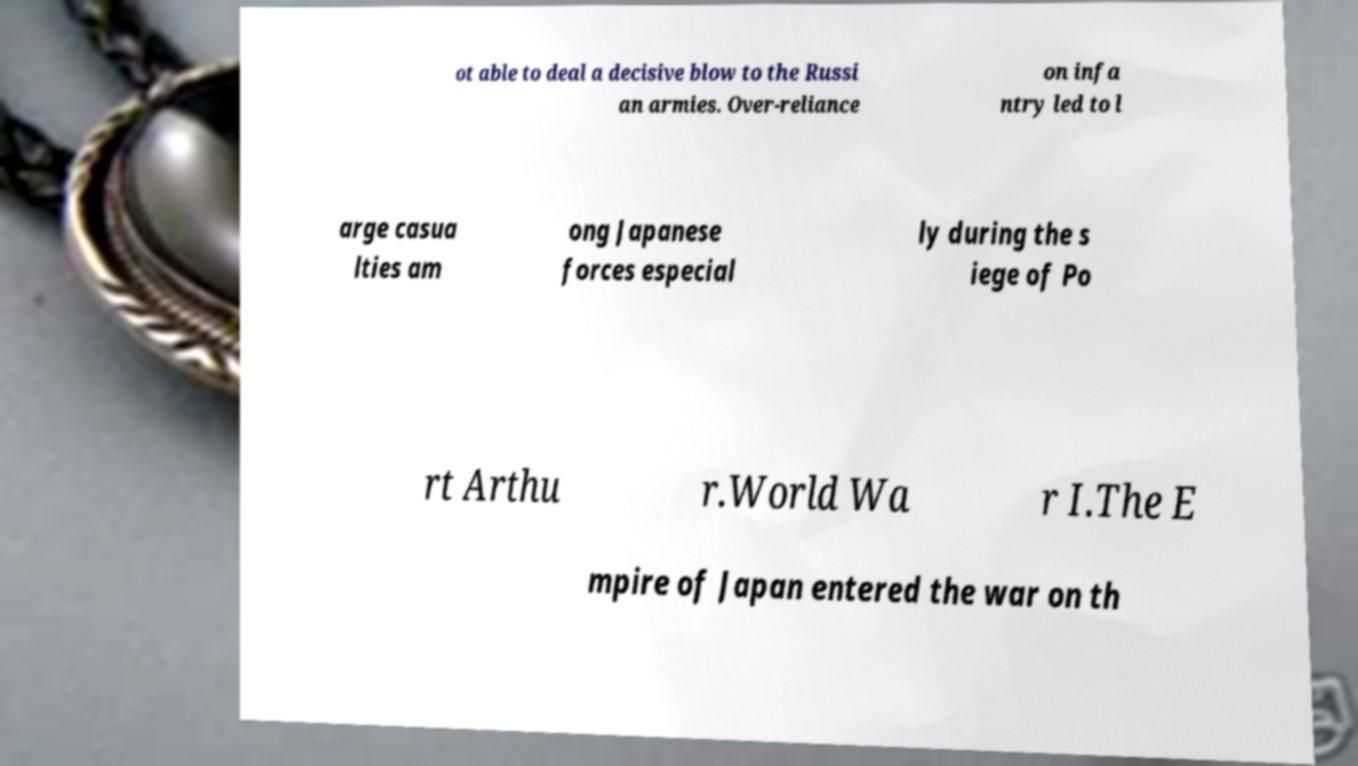Can you accurately transcribe the text from the provided image for me? ot able to deal a decisive blow to the Russi an armies. Over-reliance on infa ntry led to l arge casua lties am ong Japanese forces especial ly during the s iege of Po rt Arthu r.World Wa r I.The E mpire of Japan entered the war on th 